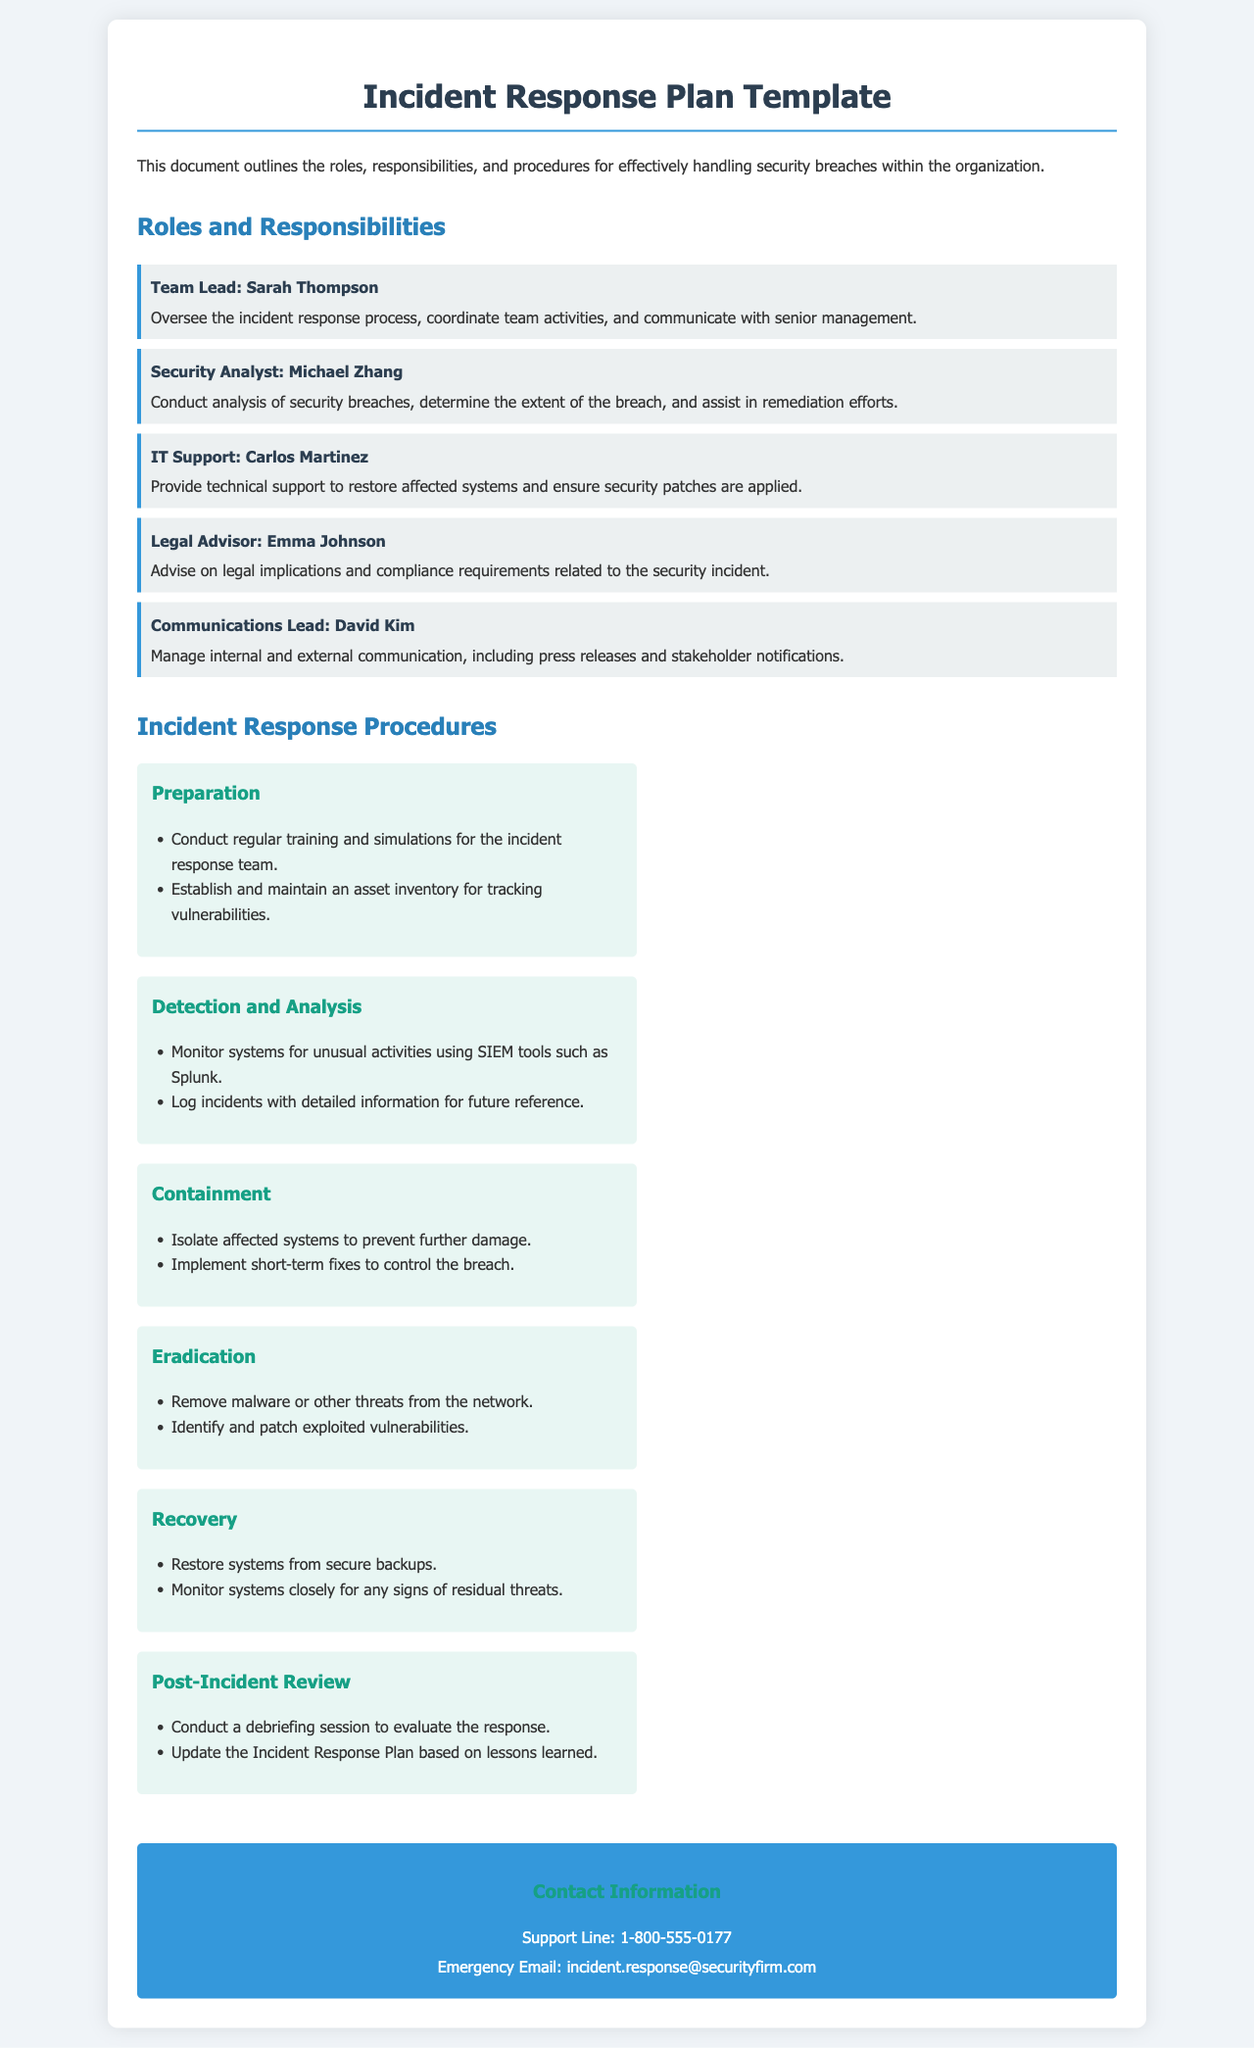What is the title of the document? The title of the document is specified in the header section, which describes the content of the document.
Answer: Incident Response Plan Template Who is the Team Lead? The document lists the roles and responsibilities of the team members, including the Team Lead.
Answer: Sarah Thompson What is Michael Zhang's role? Michael Zhang's role is described in the Roles and Responsibilities section of the document.
Answer: Security Analyst How many incident response procedures are listed? The document outlines several procedures under the Incident Response Procedures section.
Answer: Six What is the purpose of the 'Preparation' procedure? The document specifies actions to be taken under the 'Preparation' procedure as part of the incident response process.
Answer: Conduct regular training and simulations What should be done during the 'Containment' phase? The document provides specific actions to be undertaken during the containment phase of incident response.
Answer: Isolate affected systems What contact information is provided for emergencies? The document includes a section for contact information relevant to incident response situations.
Answer: incident.response@securityfirm.com What action is suggested in the 'Recovery' procedure? The 'Recovery' procedure outlines specific measures to be taken following an incident.
Answer: Restore systems from secure backups Who should manage communications during an incident? The document identifies the individual responsible for managing communications in the event of a security breach.
Answer: David Kim 